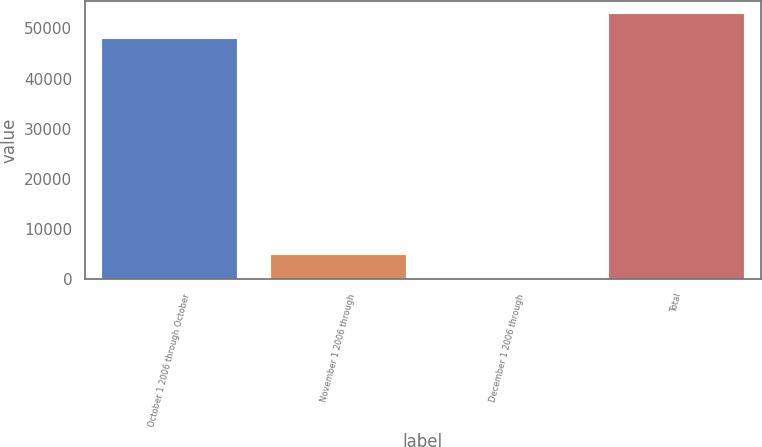Convert chart to OTSL. <chart><loc_0><loc_0><loc_500><loc_500><bar_chart><fcel>October 1 2006 through October<fcel>November 1 2006 through<fcel>December 1 2006 through<fcel>Total<nl><fcel>48000<fcel>4800.43<fcel>0.48<fcel>52799.9<nl></chart> 